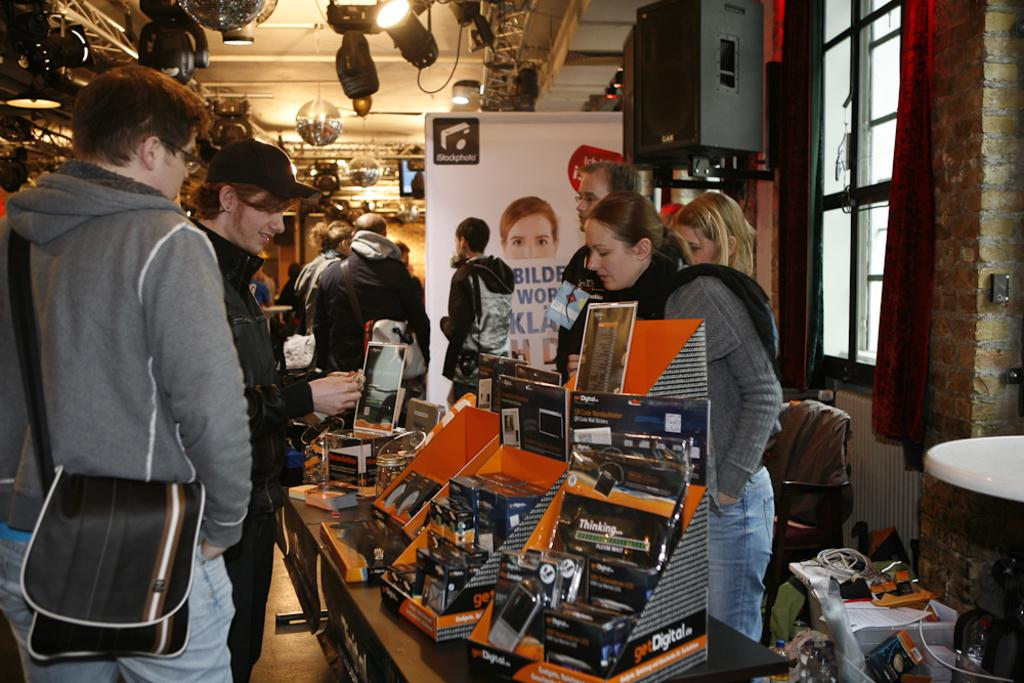What are the people in the image doing? There is a group of people standing on the floor. What can be seen on the table in the image? There are products on a table. What is visible on the right side of the image? There is a window on the right side of the image. What type of hydrant is visible through the window in the image? There is no hydrant visible through the window in the image. What type of veil is being worn by the people in the image? There is no veil being worn by the people in the image. 